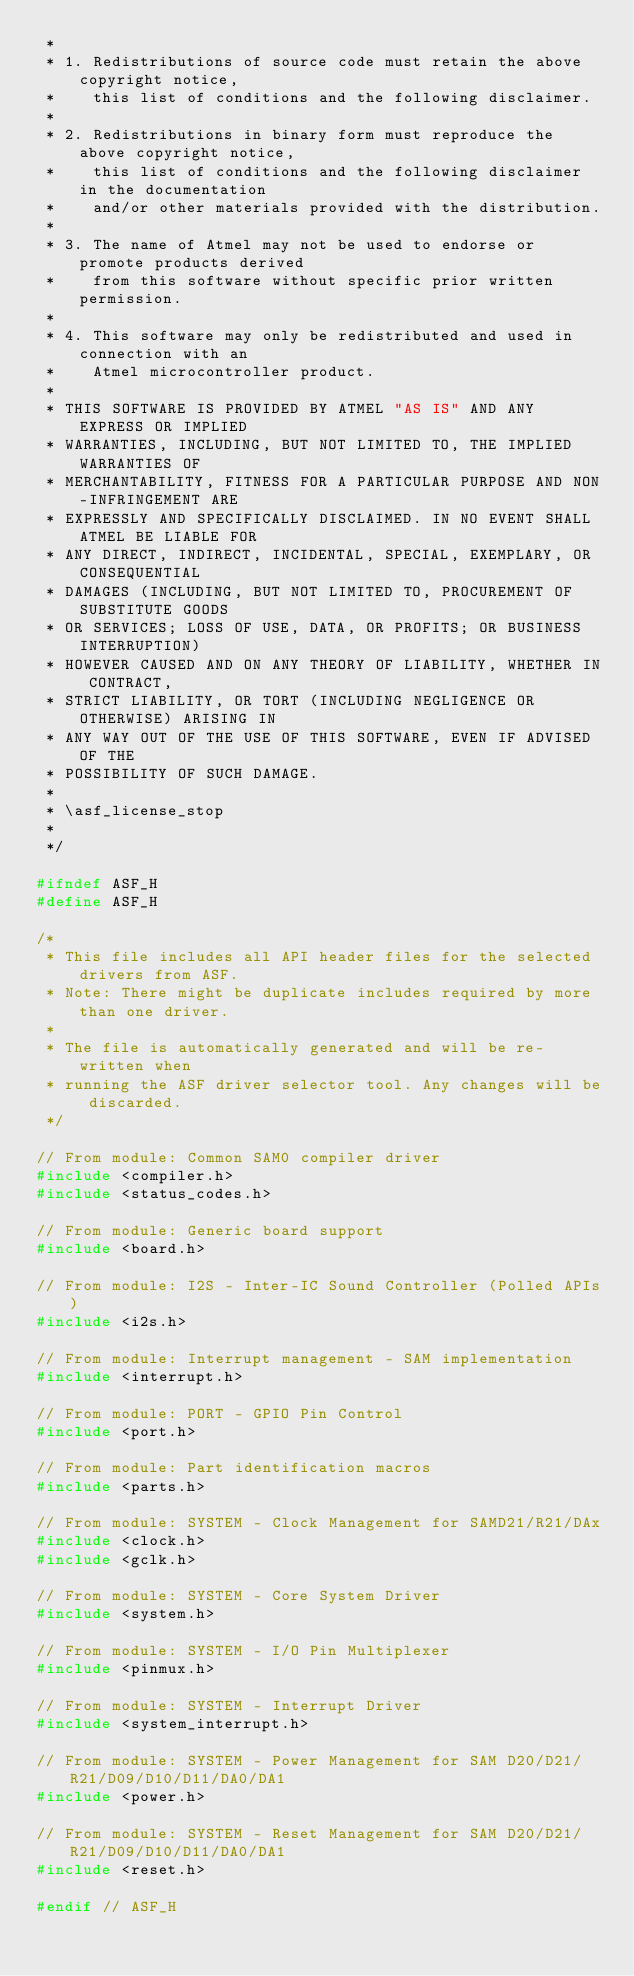Convert code to text. <code><loc_0><loc_0><loc_500><loc_500><_C_> *
 * 1. Redistributions of source code must retain the above copyright notice,
 *    this list of conditions and the following disclaimer.
 *
 * 2. Redistributions in binary form must reproduce the above copyright notice,
 *    this list of conditions and the following disclaimer in the documentation
 *    and/or other materials provided with the distribution.
 *
 * 3. The name of Atmel may not be used to endorse or promote products derived
 *    from this software without specific prior written permission.
 *
 * 4. This software may only be redistributed and used in connection with an
 *    Atmel microcontroller product.
 *
 * THIS SOFTWARE IS PROVIDED BY ATMEL "AS IS" AND ANY EXPRESS OR IMPLIED
 * WARRANTIES, INCLUDING, BUT NOT LIMITED TO, THE IMPLIED WARRANTIES OF
 * MERCHANTABILITY, FITNESS FOR A PARTICULAR PURPOSE AND NON-INFRINGEMENT ARE
 * EXPRESSLY AND SPECIFICALLY DISCLAIMED. IN NO EVENT SHALL ATMEL BE LIABLE FOR
 * ANY DIRECT, INDIRECT, INCIDENTAL, SPECIAL, EXEMPLARY, OR CONSEQUENTIAL
 * DAMAGES (INCLUDING, BUT NOT LIMITED TO, PROCUREMENT OF SUBSTITUTE GOODS
 * OR SERVICES; LOSS OF USE, DATA, OR PROFITS; OR BUSINESS INTERRUPTION)
 * HOWEVER CAUSED AND ON ANY THEORY OF LIABILITY, WHETHER IN CONTRACT,
 * STRICT LIABILITY, OR TORT (INCLUDING NEGLIGENCE OR OTHERWISE) ARISING IN
 * ANY WAY OUT OF THE USE OF THIS SOFTWARE, EVEN IF ADVISED OF THE
 * POSSIBILITY OF SUCH DAMAGE.
 *
 * \asf_license_stop
 *
 */

#ifndef ASF_H
#define ASF_H

/*
 * This file includes all API header files for the selected drivers from ASF.
 * Note: There might be duplicate includes required by more than one driver.
 *
 * The file is automatically generated and will be re-written when
 * running the ASF driver selector tool. Any changes will be discarded.
 */

// From module: Common SAM0 compiler driver
#include <compiler.h>
#include <status_codes.h>

// From module: Generic board support
#include <board.h>

// From module: I2S - Inter-IC Sound Controller (Polled APIs)
#include <i2s.h>

// From module: Interrupt management - SAM implementation
#include <interrupt.h>

// From module: PORT - GPIO Pin Control
#include <port.h>

// From module: Part identification macros
#include <parts.h>

// From module: SYSTEM - Clock Management for SAMD21/R21/DAx
#include <clock.h>
#include <gclk.h>

// From module: SYSTEM - Core System Driver
#include <system.h>

// From module: SYSTEM - I/O Pin Multiplexer
#include <pinmux.h>

// From module: SYSTEM - Interrupt Driver
#include <system_interrupt.h>

// From module: SYSTEM - Power Management for SAM D20/D21/R21/D09/D10/D11/DA0/DA1
#include <power.h>

// From module: SYSTEM - Reset Management for SAM D20/D21/R21/D09/D10/D11/DA0/DA1
#include <reset.h>

#endif // ASF_H
</code> 